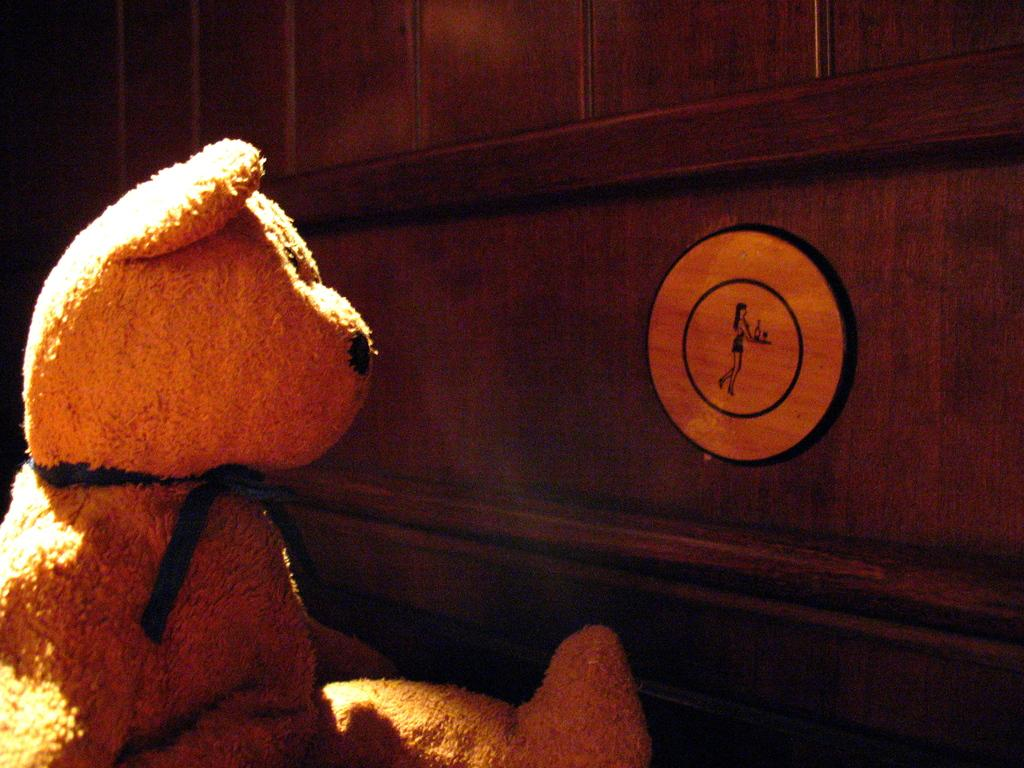What type of toy is located on the left side of the image? There is a teddy bear on the left side of the image. What material is used to construct the wall in the image? The wall in the image is made of wood. What type of advertisement can be seen on the island in the image? There is no island or advertisement present in the image; it features a teddy bear and a wooden wall. How many dolls are visible on the wooden wall in the image? There are no dolls present in the image; it only features a teddy bear and a wooden wall. 